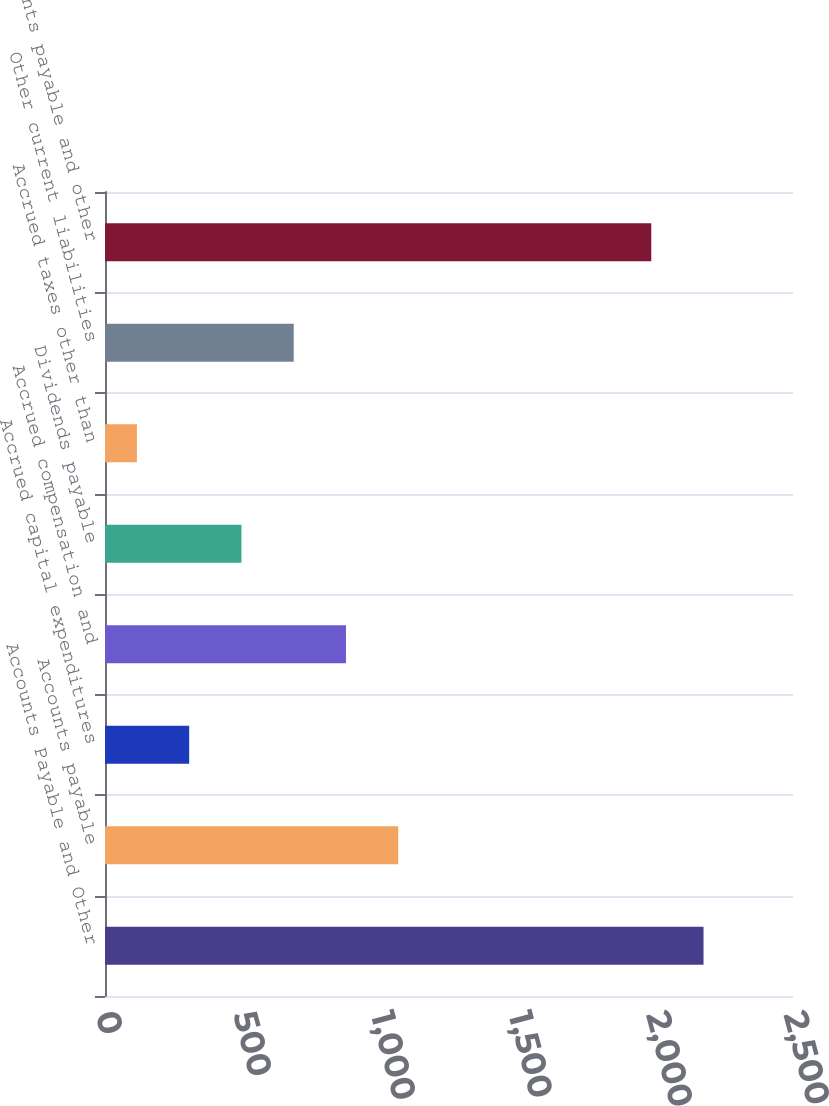<chart> <loc_0><loc_0><loc_500><loc_500><bar_chart><fcel>Accounts Payable and Other<fcel>Accounts payable<fcel>Accrued capital expenditures<fcel>Accrued compensation and<fcel>Dividends payable<fcel>Accrued taxes other than<fcel>Other current liabilities<fcel>Accounts payable and other<nl><fcel>2174.9<fcel>1065.5<fcel>305.9<fcel>875.6<fcel>495.8<fcel>116<fcel>685.7<fcel>1985<nl></chart> 